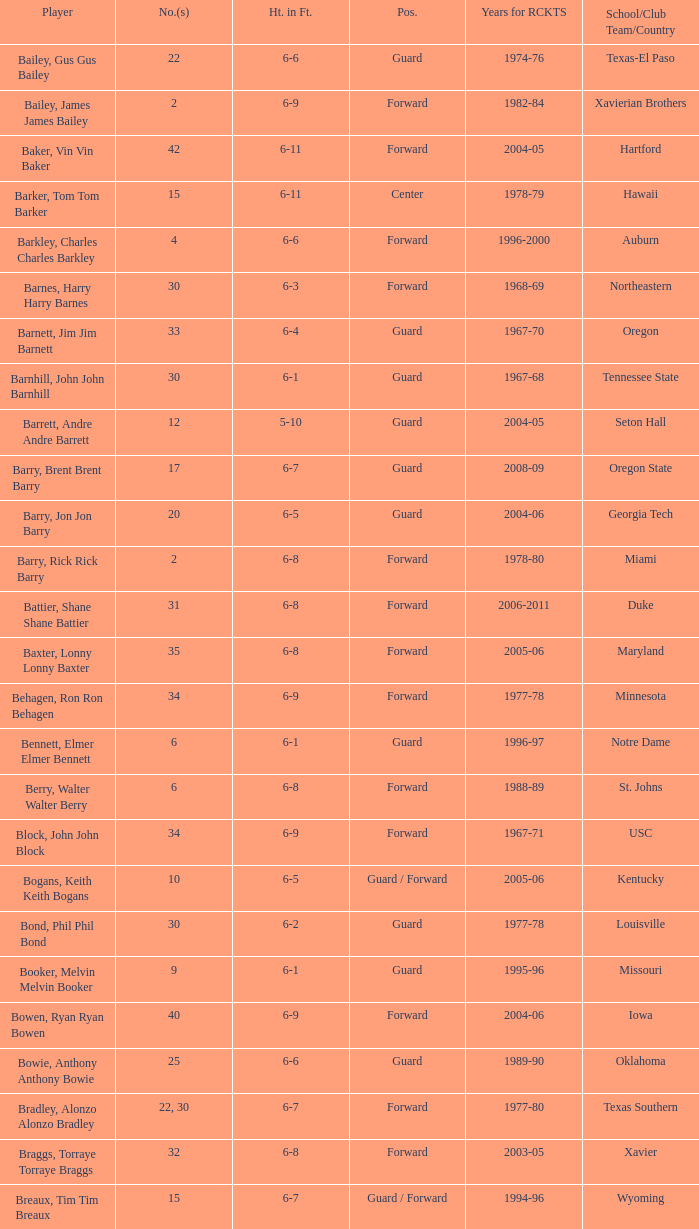Would you be able to parse every entry in this table? {'header': ['Player', 'No.(s)', 'Ht. in Ft.', 'Pos.', 'Years for RCKTS', 'School/Club Team/Country'], 'rows': [['Bailey, Gus Gus Bailey', '22', '6-6', 'Guard', '1974-76', 'Texas-El Paso'], ['Bailey, James James Bailey', '2', '6-9', 'Forward', '1982-84', 'Xavierian Brothers'], ['Baker, Vin Vin Baker', '42', '6-11', 'Forward', '2004-05', 'Hartford'], ['Barker, Tom Tom Barker', '15', '6-11', 'Center', '1978-79', 'Hawaii'], ['Barkley, Charles Charles Barkley', '4', '6-6', 'Forward', '1996-2000', 'Auburn'], ['Barnes, Harry Harry Barnes', '30', '6-3', 'Forward', '1968-69', 'Northeastern'], ['Barnett, Jim Jim Barnett', '33', '6-4', 'Guard', '1967-70', 'Oregon'], ['Barnhill, John John Barnhill', '30', '6-1', 'Guard', '1967-68', 'Tennessee State'], ['Barrett, Andre Andre Barrett', '12', '5-10', 'Guard', '2004-05', 'Seton Hall'], ['Barry, Brent Brent Barry', '17', '6-7', 'Guard', '2008-09', 'Oregon State'], ['Barry, Jon Jon Barry', '20', '6-5', 'Guard', '2004-06', 'Georgia Tech'], ['Barry, Rick Rick Barry', '2', '6-8', 'Forward', '1978-80', 'Miami'], ['Battier, Shane Shane Battier', '31', '6-8', 'Forward', '2006-2011', 'Duke'], ['Baxter, Lonny Lonny Baxter', '35', '6-8', 'Forward', '2005-06', 'Maryland'], ['Behagen, Ron Ron Behagen', '34', '6-9', 'Forward', '1977-78', 'Minnesota'], ['Bennett, Elmer Elmer Bennett', '6', '6-1', 'Guard', '1996-97', 'Notre Dame'], ['Berry, Walter Walter Berry', '6', '6-8', 'Forward', '1988-89', 'St. Johns'], ['Block, John John Block', '34', '6-9', 'Forward', '1967-71', 'USC'], ['Bogans, Keith Keith Bogans', '10', '6-5', 'Guard / Forward', '2005-06', 'Kentucky'], ['Bond, Phil Phil Bond', '30', '6-2', 'Guard', '1977-78', 'Louisville'], ['Booker, Melvin Melvin Booker', '9', '6-1', 'Guard', '1995-96', 'Missouri'], ['Bowen, Ryan Ryan Bowen', '40', '6-9', 'Forward', '2004-06', 'Iowa'], ['Bowie, Anthony Anthony Bowie', '25', '6-6', 'Guard', '1989-90', 'Oklahoma'], ['Bradley, Alonzo Alonzo Bradley', '22, 30', '6-7', 'Forward', '1977-80', 'Texas Southern'], ['Braggs, Torraye Torraye Braggs', '32', '6-8', 'Forward', '2003-05', 'Xavier'], ['Breaux, Tim Tim Breaux', '15', '6-7', 'Guard / Forward', '1994-96', 'Wyoming'], ['Britt, Tyrone Tyrone Britt', '31', '6-4', 'Guard', '1967-68', 'Johnson C. Smith'], ['Brooks, Aaron Aaron Brooks', '0', '6-0', 'Guard', '2007-2011, 2013', 'Oregon'], ['Brooks, Scott Scott Brooks', '1', '5-11', 'Guard', '1992-95', 'UC-Irvine'], ['Brown, Chucky Chucky Brown', '52', '6-8', 'Forward', '1994-96', 'North Carolina'], ['Brown, Tony Tony Brown', '35', '6-6', 'Forward', '1988-89', 'Arkansas'], ['Brown, Tierre Tierre Brown', '10', '6-2', 'Guard', '2001-02', 'McNesse State'], ['Brunson, Rick Rick Brunson', '9', '6-4', 'Guard', '2005-06', 'Temple'], ['Bryant, Joe Joe Bryant', '22', '6-9', 'Forward / Guard', '1982-83', 'LaSalle'], ['Bryant, Mark Mark Bryant', '2', '6-9', 'Forward', '1995-96', 'Seton Hall'], ['Budinger, Chase Chase Budinger', '10', '6-7', 'Forward', '2009-2012', 'Arizona'], ['Bullard, Matt Matt Bullard', '50', '6-10', 'Forward', '1990-94, 1996-2001', 'Iowa']]} What school did the forward whose number is 10 belong to? Arizona. 